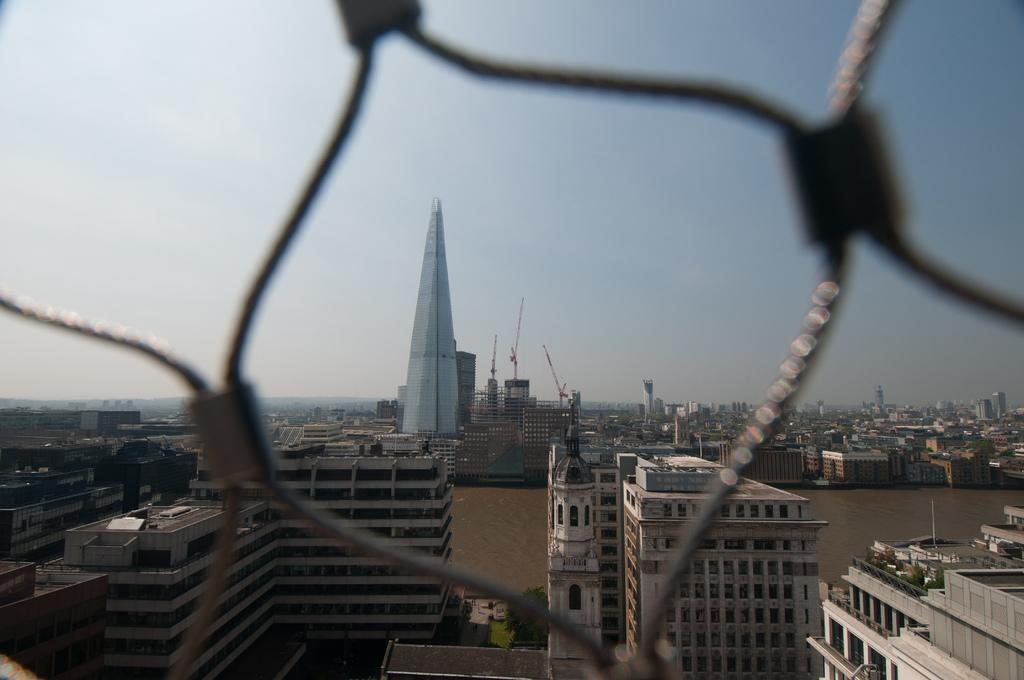What type of structures can be seen in the image? There are buildings in the image. What is visible at the top of the image? The sky is visible at the top of the image. What type of underwear is hanging on the clothesline in the image? There is no clothesline or underwear present in the image. What is happening behind the buildings in the image? There is no information about what is happening behind the buildings in the image, as the provided facts only mention the buildings and the sky. 